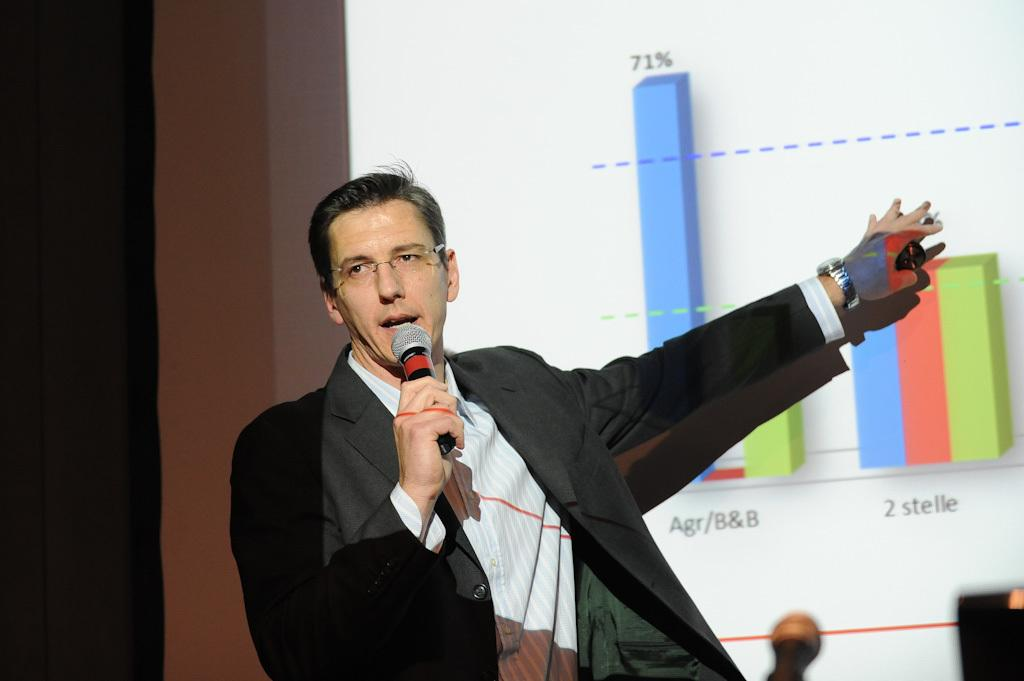Who is the main subject in the image? There is a man in the image. What is the man wearing? The man is wearing a blazer. What is the man holding in the image? The man is holding a microphone. What is the man doing in the image? The man is speaking. What can be seen in the background of the image? There is a projector screen in the background of the image. Can you see the queen kissing the man in the image? There is no queen or kissing depicted in the image; it features a man holding a microphone and speaking. What type of sponge is being used by the man to clean the projector screen? There is no sponge present in the image, and the man is not cleaning the projector screen. 